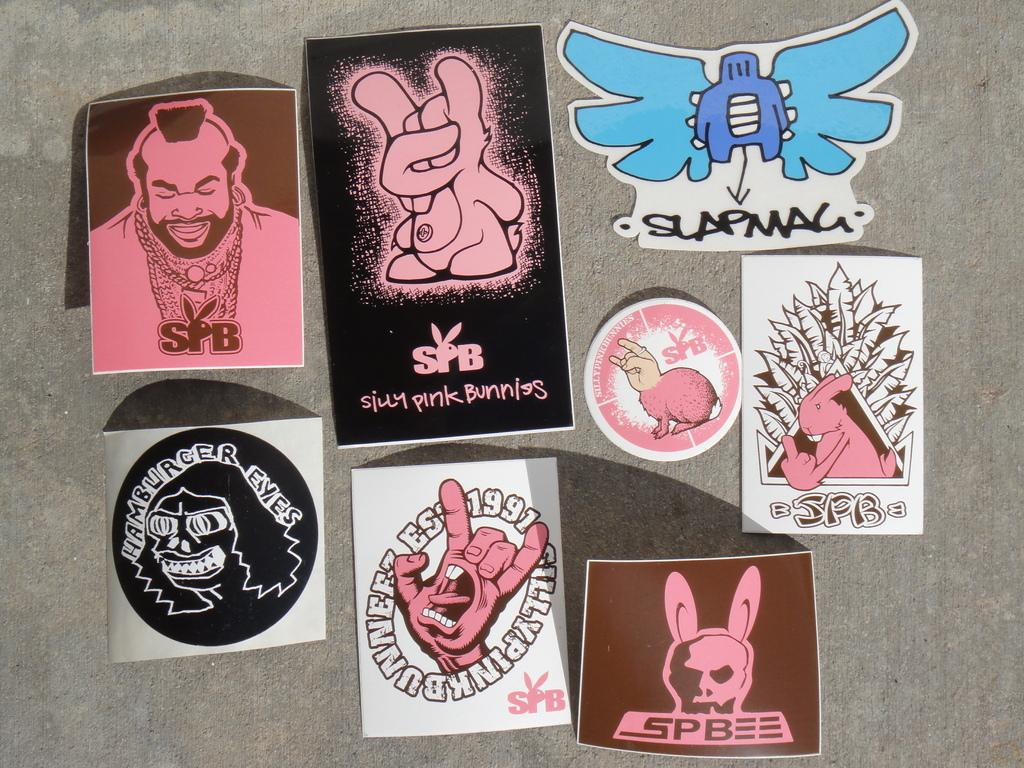What is present on the surface in the image? There are stickers on a surface in the image. How much honey is dripping from the tree in the image? There is no tree or honey present in the image; it only features stickers on a surface. 